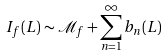Convert formula to latex. <formula><loc_0><loc_0><loc_500><loc_500>I _ { f } ( L ) \sim \mathcal { M } _ { f } + \sum _ { n = 1 } ^ { \infty } b _ { n } ( L )</formula> 